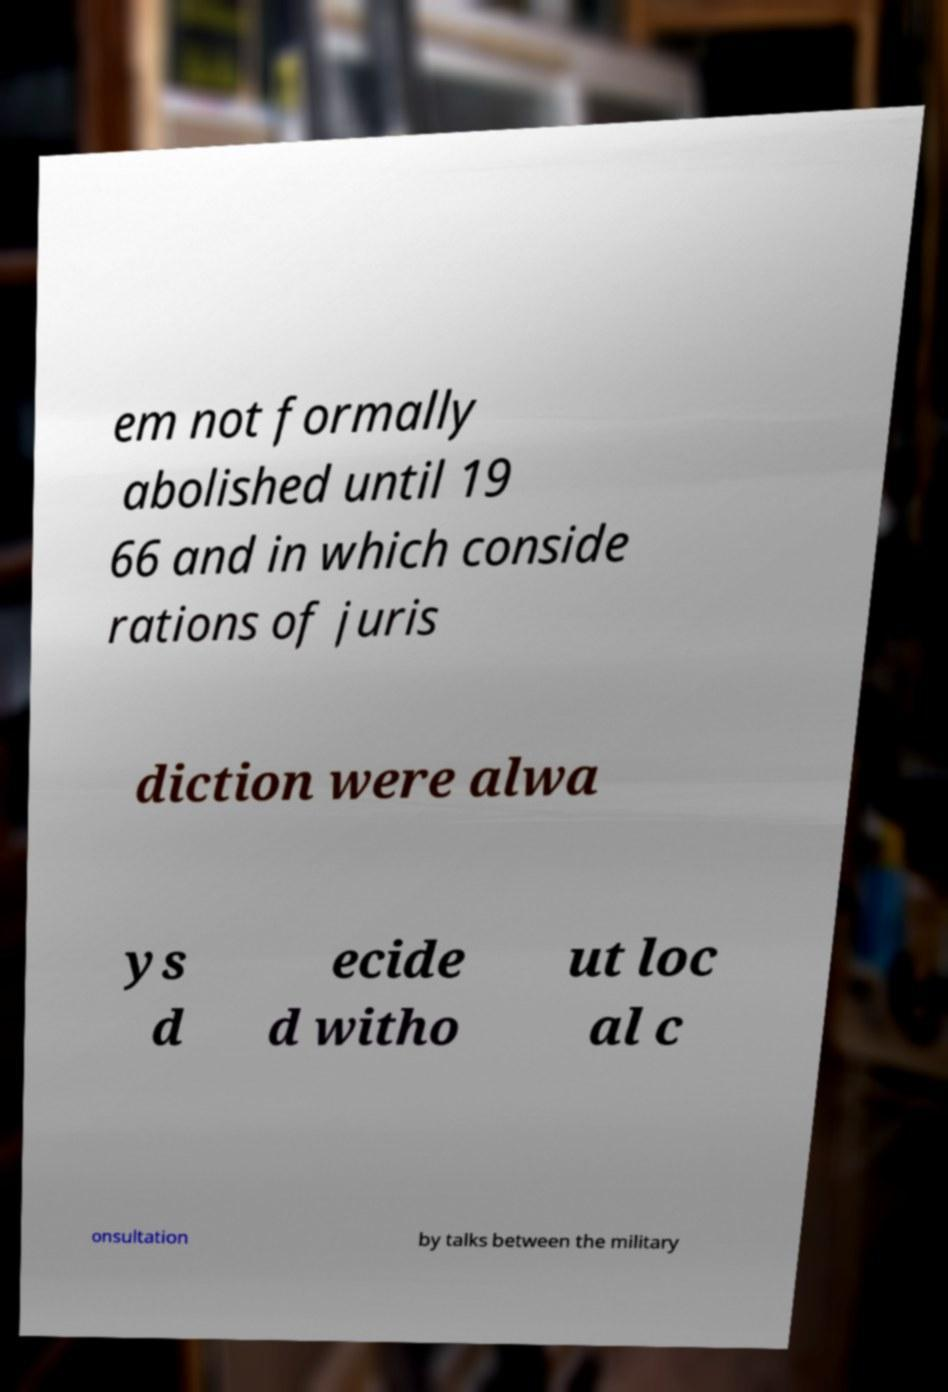There's text embedded in this image that I need extracted. Can you transcribe it verbatim? em not formally abolished until 19 66 and in which conside rations of juris diction were alwa ys d ecide d witho ut loc al c onsultation by talks between the military 